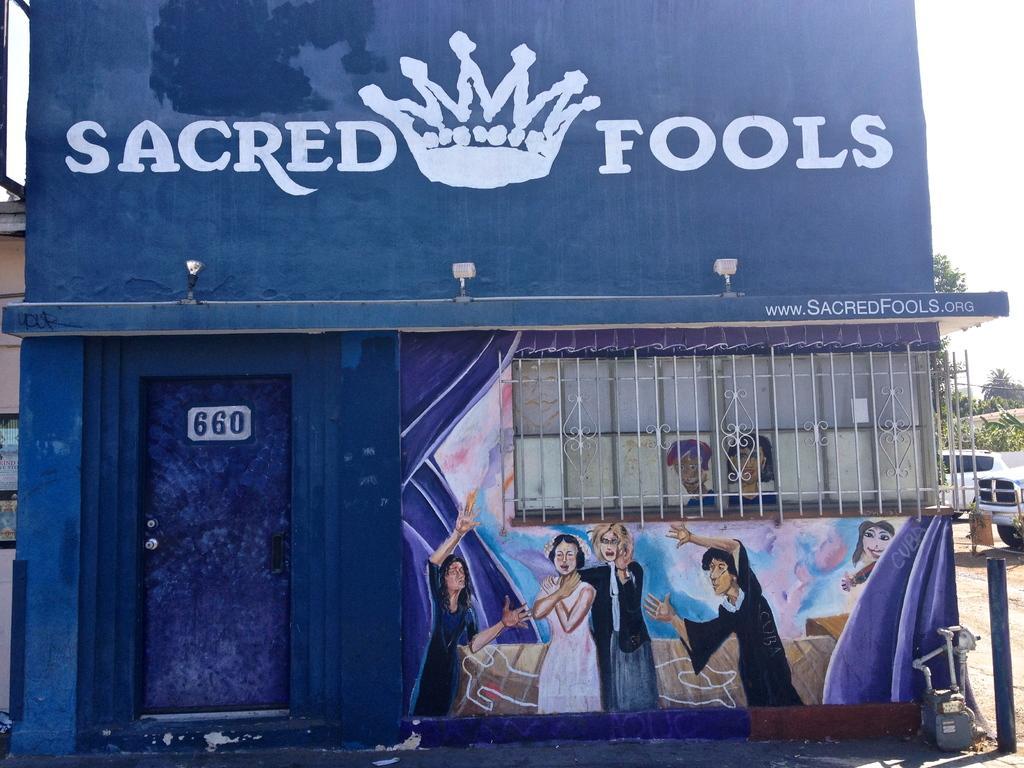How would you summarize this image in a sentence or two? In this image there is a house with paintings on it, behind the house there are cars, trees and other houses 